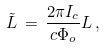<formula> <loc_0><loc_0><loc_500><loc_500>\tilde { L } \, = \, \frac { 2 \pi I _ { c } } { c \Phi _ { o } } L \, ,</formula> 